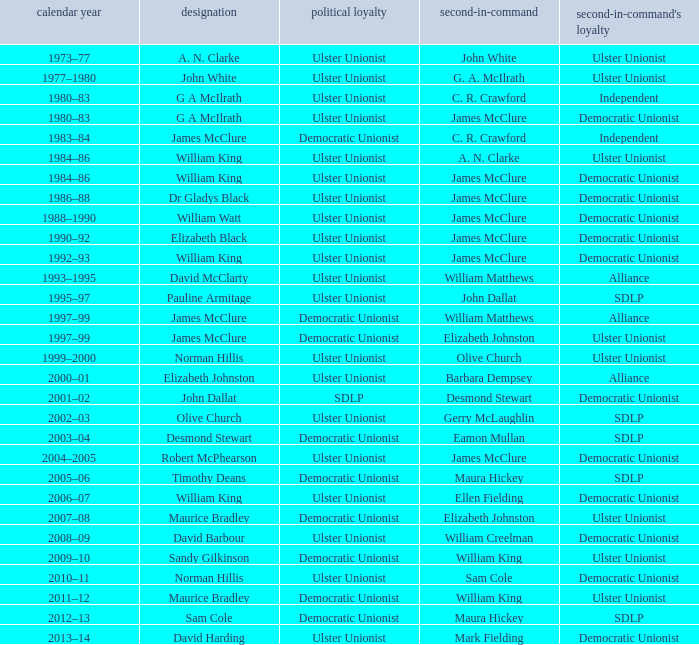What is the Deputy's affiliation in 1992–93? Democratic Unionist. 